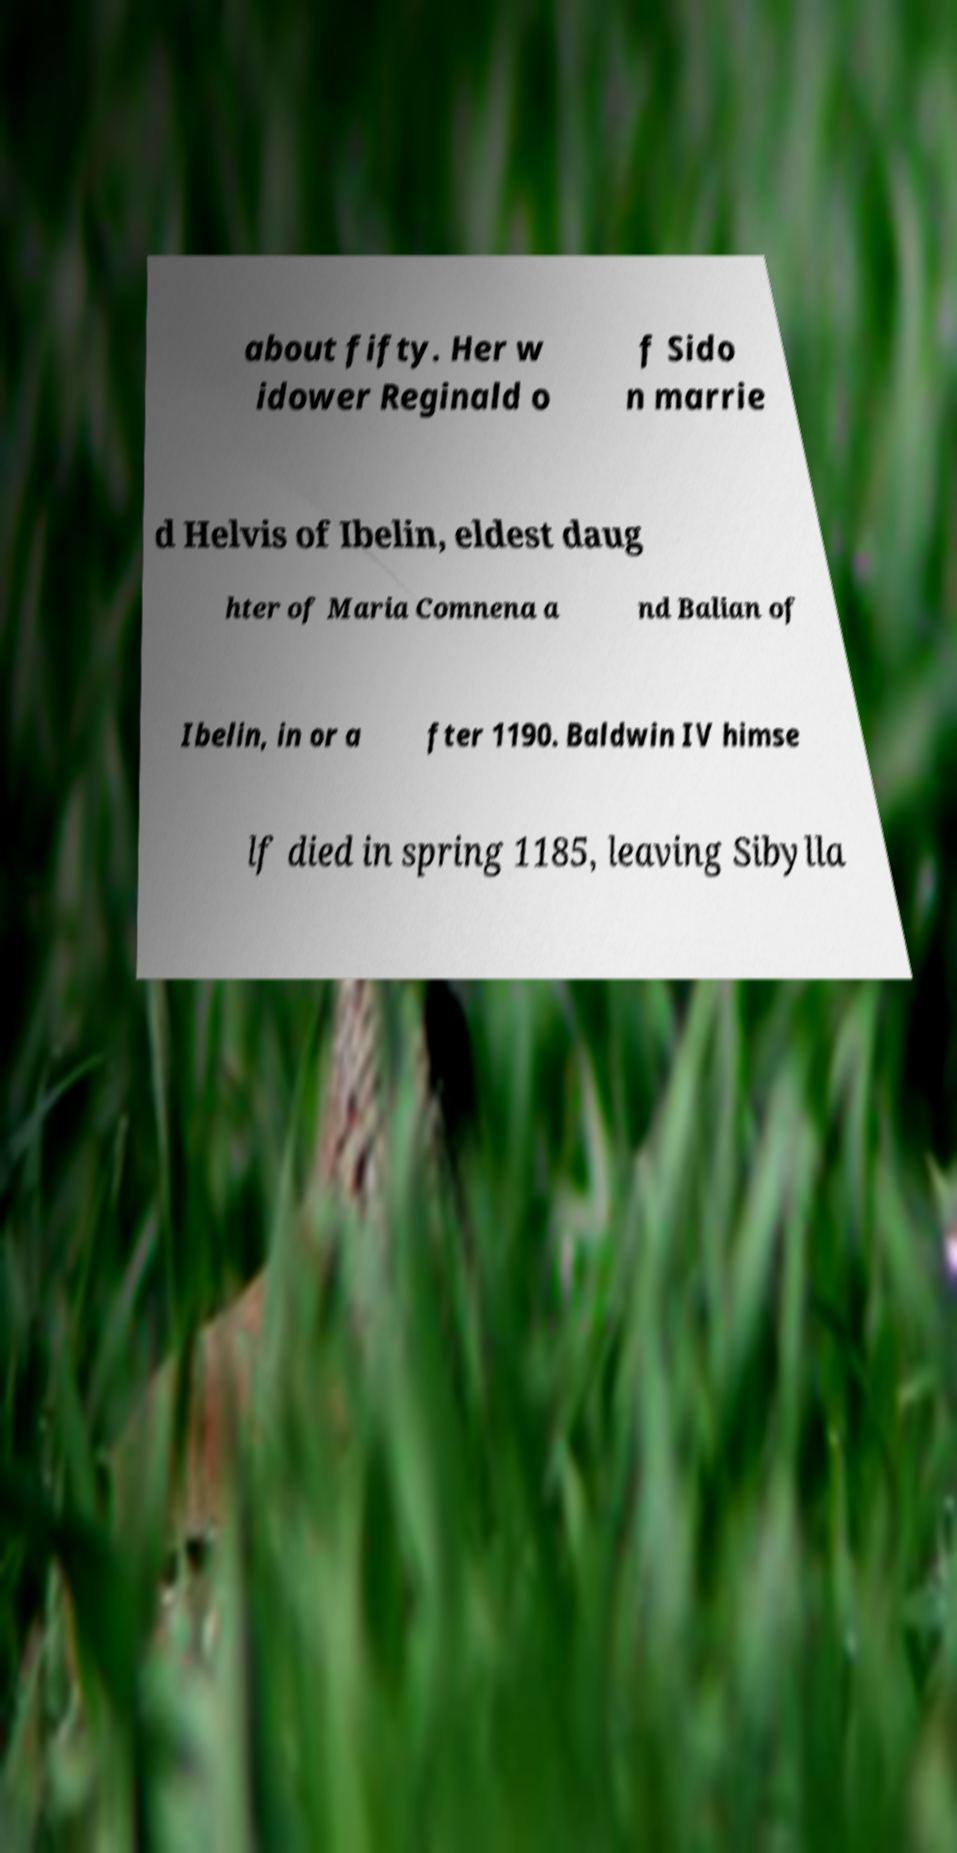Could you extract and type out the text from this image? about fifty. Her w idower Reginald o f Sido n marrie d Helvis of Ibelin, eldest daug hter of Maria Comnena a nd Balian of Ibelin, in or a fter 1190. Baldwin IV himse lf died in spring 1185, leaving Sibylla 